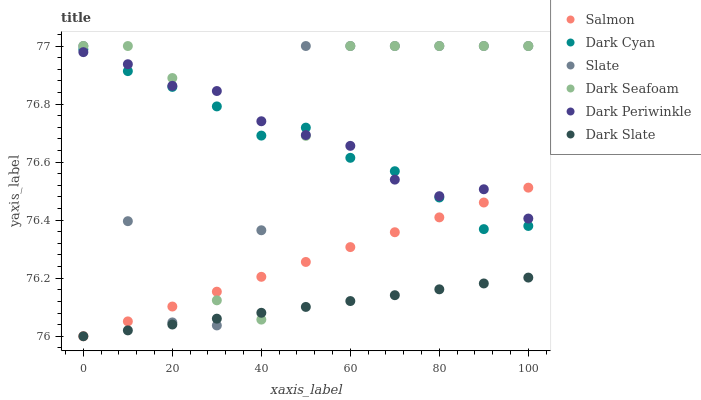Does Dark Slate have the minimum area under the curve?
Answer yes or no. Yes. Does Dark Seafoam have the maximum area under the curve?
Answer yes or no. Yes. Does Salmon have the minimum area under the curve?
Answer yes or no. No. Does Salmon have the maximum area under the curve?
Answer yes or no. No. Is Salmon the smoothest?
Answer yes or no. Yes. Is Dark Seafoam the roughest?
Answer yes or no. Yes. Is Dark Slate the smoothest?
Answer yes or no. No. Is Dark Slate the roughest?
Answer yes or no. No. Does Salmon have the lowest value?
Answer yes or no. Yes. Does Dark Seafoam have the lowest value?
Answer yes or no. No. Does Dark Seafoam have the highest value?
Answer yes or no. Yes. Does Salmon have the highest value?
Answer yes or no. No. Is Dark Slate less than Dark Periwinkle?
Answer yes or no. Yes. Is Dark Periwinkle greater than Dark Slate?
Answer yes or no. Yes. Does Dark Slate intersect Salmon?
Answer yes or no. Yes. Is Dark Slate less than Salmon?
Answer yes or no. No. Is Dark Slate greater than Salmon?
Answer yes or no. No. Does Dark Slate intersect Dark Periwinkle?
Answer yes or no. No. 